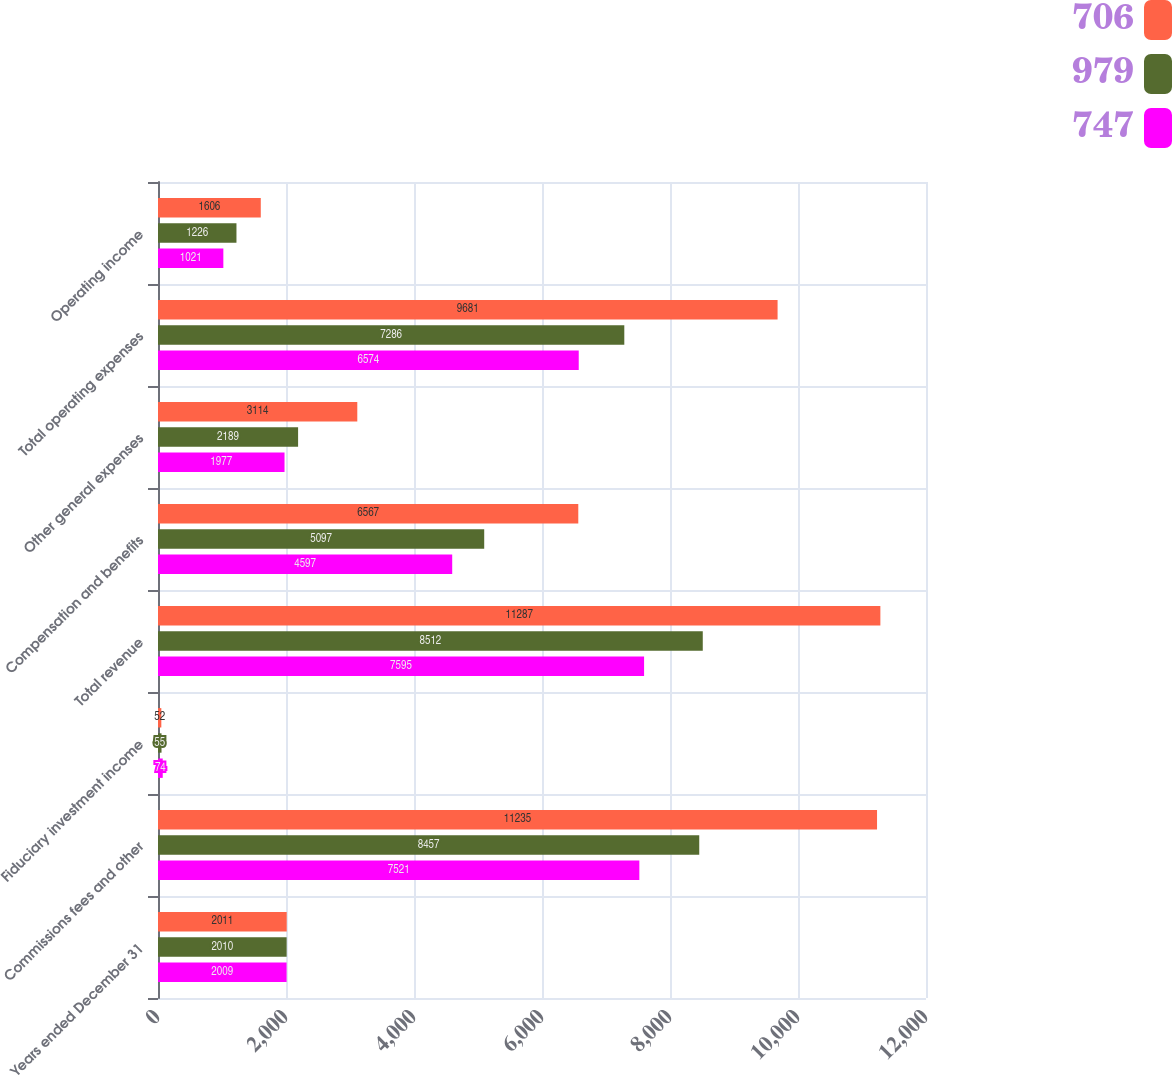<chart> <loc_0><loc_0><loc_500><loc_500><stacked_bar_chart><ecel><fcel>Years ended December 31<fcel>Commissions fees and other<fcel>Fiduciary investment income<fcel>Total revenue<fcel>Compensation and benefits<fcel>Other general expenses<fcel>Total operating expenses<fcel>Operating income<nl><fcel>706<fcel>2011<fcel>11235<fcel>52<fcel>11287<fcel>6567<fcel>3114<fcel>9681<fcel>1606<nl><fcel>979<fcel>2010<fcel>8457<fcel>55<fcel>8512<fcel>5097<fcel>2189<fcel>7286<fcel>1226<nl><fcel>747<fcel>2009<fcel>7521<fcel>74<fcel>7595<fcel>4597<fcel>1977<fcel>6574<fcel>1021<nl></chart> 